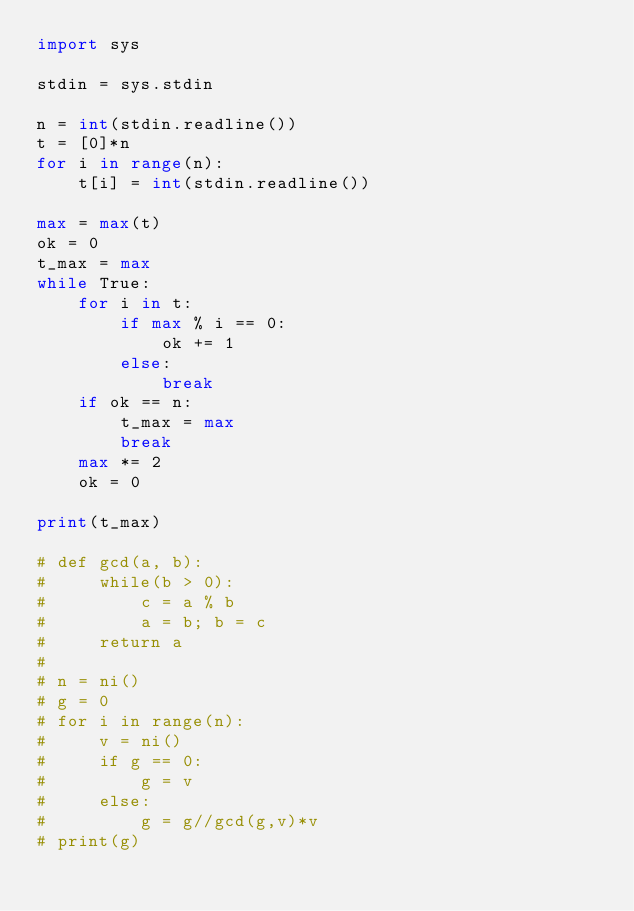<code> <loc_0><loc_0><loc_500><loc_500><_Python_>import sys

stdin = sys.stdin

n = int(stdin.readline())
t = [0]*n
for i in range(n):
    t[i] = int(stdin.readline())

max = max(t)
ok = 0
t_max = max
while True:
    for i in t:
        if max % i == 0:
            ok += 1
        else:
            break
    if ok == n:
        t_max = max
        break
    max *= 2
    ok = 0

print(t_max)

# def gcd(a, b):
#     while(b > 0):
#         c = a % b
#         a = b; b = c
#     return a
#
# n = ni()
# g = 0
# for i in range(n):
#     v = ni()
#     if g == 0:
#         g = v
#     else:
#         g = g//gcd(g,v)*v
# print(g)
</code> 